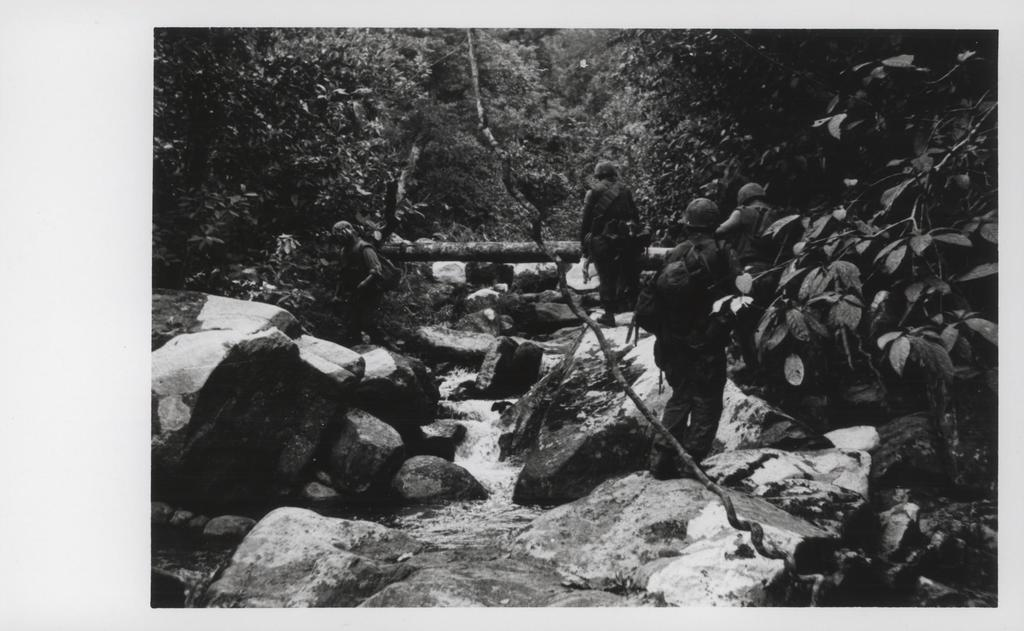What type of natural elements can be seen in the image? There are rocks and water visible in the image. What are the people in the image wearing? The people in the image are wearing helmets. What are the people carrying in the image? The people are carrying bags. What can be seen in the background of the image? There are trees in the background of the image. How many jellyfish can be seen swimming in the water in the image? There are no jellyfish visible in the image; it only shows rocks and water. 